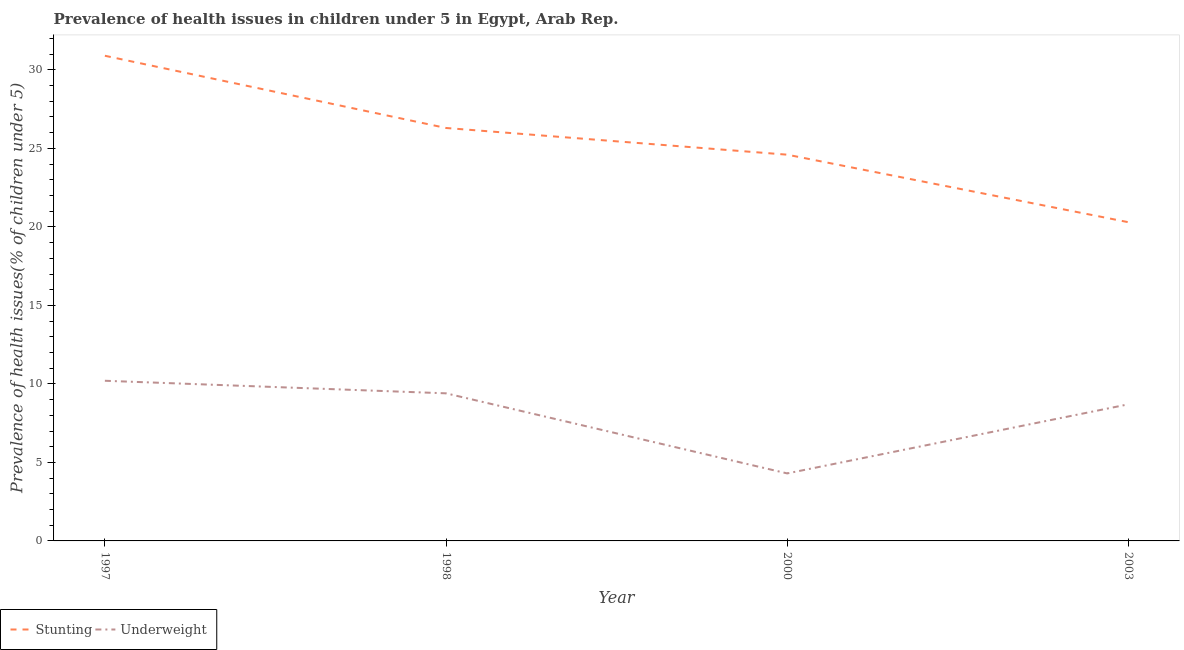How many different coloured lines are there?
Offer a very short reply. 2. Does the line corresponding to percentage of underweight children intersect with the line corresponding to percentage of stunted children?
Your answer should be very brief. No. Is the number of lines equal to the number of legend labels?
Offer a very short reply. Yes. What is the percentage of underweight children in 1998?
Your answer should be compact. 9.4. Across all years, what is the maximum percentage of stunted children?
Keep it short and to the point. 30.9. Across all years, what is the minimum percentage of underweight children?
Make the answer very short. 4.3. In which year was the percentage of underweight children minimum?
Give a very brief answer. 2000. What is the total percentage of stunted children in the graph?
Provide a short and direct response. 102.1. What is the difference between the percentage of underweight children in 1997 and that in 2003?
Your answer should be compact. 1.5. What is the difference between the percentage of underweight children in 1997 and the percentage of stunted children in 1998?
Give a very brief answer. -16.1. What is the average percentage of stunted children per year?
Offer a very short reply. 25.52. In the year 1998, what is the difference between the percentage of stunted children and percentage of underweight children?
Give a very brief answer. 16.9. What is the ratio of the percentage of underweight children in 2000 to that in 2003?
Provide a short and direct response. 0.49. What is the difference between the highest and the second highest percentage of stunted children?
Make the answer very short. 4.6. What is the difference between the highest and the lowest percentage of underweight children?
Give a very brief answer. 5.9. In how many years, is the percentage of stunted children greater than the average percentage of stunted children taken over all years?
Provide a short and direct response. 2. Does the percentage of stunted children monotonically increase over the years?
Keep it short and to the point. No. Is the percentage of underweight children strictly greater than the percentage of stunted children over the years?
Make the answer very short. No. Is the percentage of underweight children strictly less than the percentage of stunted children over the years?
Provide a succinct answer. Yes. How many years are there in the graph?
Make the answer very short. 4. Are the values on the major ticks of Y-axis written in scientific E-notation?
Provide a short and direct response. No. Does the graph contain grids?
Ensure brevity in your answer.  No. What is the title of the graph?
Provide a short and direct response. Prevalence of health issues in children under 5 in Egypt, Arab Rep. Does "Public funds" appear as one of the legend labels in the graph?
Your answer should be compact. No. What is the label or title of the X-axis?
Keep it short and to the point. Year. What is the label or title of the Y-axis?
Provide a succinct answer. Prevalence of health issues(% of children under 5). What is the Prevalence of health issues(% of children under 5) of Stunting in 1997?
Ensure brevity in your answer.  30.9. What is the Prevalence of health issues(% of children under 5) of Underweight in 1997?
Your answer should be very brief. 10.2. What is the Prevalence of health issues(% of children under 5) of Stunting in 1998?
Your response must be concise. 26.3. What is the Prevalence of health issues(% of children under 5) of Underweight in 1998?
Your response must be concise. 9.4. What is the Prevalence of health issues(% of children under 5) in Stunting in 2000?
Provide a succinct answer. 24.6. What is the Prevalence of health issues(% of children under 5) in Underweight in 2000?
Your answer should be compact. 4.3. What is the Prevalence of health issues(% of children under 5) of Stunting in 2003?
Your answer should be very brief. 20.3. What is the Prevalence of health issues(% of children under 5) of Underweight in 2003?
Keep it short and to the point. 8.7. Across all years, what is the maximum Prevalence of health issues(% of children under 5) in Stunting?
Provide a short and direct response. 30.9. Across all years, what is the maximum Prevalence of health issues(% of children under 5) of Underweight?
Give a very brief answer. 10.2. Across all years, what is the minimum Prevalence of health issues(% of children under 5) in Stunting?
Provide a short and direct response. 20.3. Across all years, what is the minimum Prevalence of health issues(% of children under 5) of Underweight?
Provide a short and direct response. 4.3. What is the total Prevalence of health issues(% of children under 5) in Stunting in the graph?
Give a very brief answer. 102.1. What is the total Prevalence of health issues(% of children under 5) in Underweight in the graph?
Give a very brief answer. 32.6. What is the difference between the Prevalence of health issues(% of children under 5) in Stunting in 1997 and that in 1998?
Offer a terse response. 4.6. What is the difference between the Prevalence of health issues(% of children under 5) of Underweight in 1997 and that in 2000?
Provide a short and direct response. 5.9. What is the difference between the Prevalence of health issues(% of children under 5) in Stunting in 1997 and that in 2003?
Your response must be concise. 10.6. What is the difference between the Prevalence of health issues(% of children under 5) of Underweight in 1997 and that in 2003?
Ensure brevity in your answer.  1.5. What is the difference between the Prevalence of health issues(% of children under 5) of Stunting in 1998 and that in 2000?
Keep it short and to the point. 1.7. What is the difference between the Prevalence of health issues(% of children under 5) in Stunting in 1998 and that in 2003?
Offer a very short reply. 6. What is the difference between the Prevalence of health issues(% of children under 5) in Underweight in 1998 and that in 2003?
Your response must be concise. 0.7. What is the difference between the Prevalence of health issues(% of children under 5) of Stunting in 2000 and that in 2003?
Keep it short and to the point. 4.3. What is the difference between the Prevalence of health issues(% of children under 5) of Stunting in 1997 and the Prevalence of health issues(% of children under 5) of Underweight in 1998?
Ensure brevity in your answer.  21.5. What is the difference between the Prevalence of health issues(% of children under 5) in Stunting in 1997 and the Prevalence of health issues(% of children under 5) in Underweight in 2000?
Your answer should be very brief. 26.6. What is the difference between the Prevalence of health issues(% of children under 5) of Stunting in 1997 and the Prevalence of health issues(% of children under 5) of Underweight in 2003?
Keep it short and to the point. 22.2. What is the difference between the Prevalence of health issues(% of children under 5) of Stunting in 1998 and the Prevalence of health issues(% of children under 5) of Underweight in 2000?
Your answer should be very brief. 22. What is the difference between the Prevalence of health issues(% of children under 5) in Stunting in 1998 and the Prevalence of health issues(% of children under 5) in Underweight in 2003?
Provide a short and direct response. 17.6. What is the average Prevalence of health issues(% of children under 5) of Stunting per year?
Offer a very short reply. 25.52. What is the average Prevalence of health issues(% of children under 5) in Underweight per year?
Keep it short and to the point. 8.15. In the year 1997, what is the difference between the Prevalence of health issues(% of children under 5) of Stunting and Prevalence of health issues(% of children under 5) of Underweight?
Offer a terse response. 20.7. In the year 2000, what is the difference between the Prevalence of health issues(% of children under 5) of Stunting and Prevalence of health issues(% of children under 5) of Underweight?
Your answer should be compact. 20.3. In the year 2003, what is the difference between the Prevalence of health issues(% of children under 5) in Stunting and Prevalence of health issues(% of children under 5) in Underweight?
Ensure brevity in your answer.  11.6. What is the ratio of the Prevalence of health issues(% of children under 5) in Stunting in 1997 to that in 1998?
Your answer should be very brief. 1.17. What is the ratio of the Prevalence of health issues(% of children under 5) of Underweight in 1997 to that in 1998?
Offer a terse response. 1.09. What is the ratio of the Prevalence of health issues(% of children under 5) in Stunting in 1997 to that in 2000?
Your response must be concise. 1.26. What is the ratio of the Prevalence of health issues(% of children under 5) in Underweight in 1997 to that in 2000?
Your answer should be compact. 2.37. What is the ratio of the Prevalence of health issues(% of children under 5) of Stunting in 1997 to that in 2003?
Your answer should be compact. 1.52. What is the ratio of the Prevalence of health issues(% of children under 5) of Underweight in 1997 to that in 2003?
Your response must be concise. 1.17. What is the ratio of the Prevalence of health issues(% of children under 5) in Stunting in 1998 to that in 2000?
Provide a succinct answer. 1.07. What is the ratio of the Prevalence of health issues(% of children under 5) in Underweight in 1998 to that in 2000?
Offer a terse response. 2.19. What is the ratio of the Prevalence of health issues(% of children under 5) of Stunting in 1998 to that in 2003?
Ensure brevity in your answer.  1.3. What is the ratio of the Prevalence of health issues(% of children under 5) in Underweight in 1998 to that in 2003?
Offer a very short reply. 1.08. What is the ratio of the Prevalence of health issues(% of children under 5) of Stunting in 2000 to that in 2003?
Offer a very short reply. 1.21. What is the ratio of the Prevalence of health issues(% of children under 5) in Underweight in 2000 to that in 2003?
Ensure brevity in your answer.  0.49. What is the difference between the highest and the second highest Prevalence of health issues(% of children under 5) in Stunting?
Give a very brief answer. 4.6. What is the difference between the highest and the second highest Prevalence of health issues(% of children under 5) of Underweight?
Offer a terse response. 0.8. What is the difference between the highest and the lowest Prevalence of health issues(% of children under 5) in Underweight?
Provide a succinct answer. 5.9. 